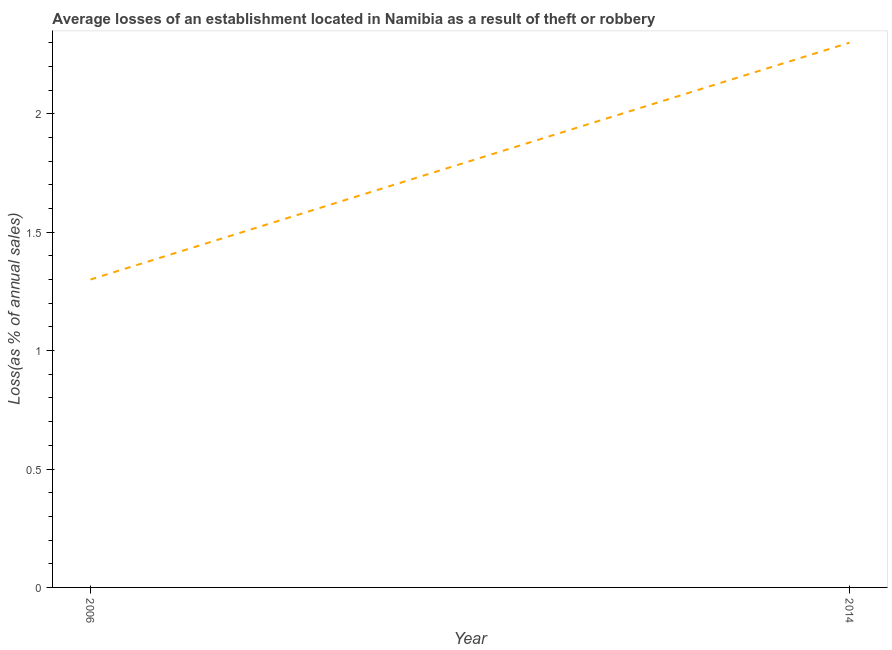Across all years, what is the maximum losses due to theft?
Provide a succinct answer. 2.3. What is the sum of the losses due to theft?
Your response must be concise. 3.6. What is the difference between the losses due to theft in 2006 and 2014?
Give a very brief answer. -1. What is the average losses due to theft per year?
Make the answer very short. 1.8. What is the median losses due to theft?
Make the answer very short. 1.8. Do a majority of the years between 2006 and 2014 (inclusive) have losses due to theft greater than 2 %?
Ensure brevity in your answer.  No. What is the ratio of the losses due to theft in 2006 to that in 2014?
Give a very brief answer. 0.57. Is the losses due to theft in 2006 less than that in 2014?
Give a very brief answer. Yes. In how many years, is the losses due to theft greater than the average losses due to theft taken over all years?
Your answer should be very brief. 1. What is the difference between two consecutive major ticks on the Y-axis?
Offer a terse response. 0.5. Does the graph contain any zero values?
Provide a short and direct response. No. Does the graph contain grids?
Give a very brief answer. No. What is the title of the graph?
Ensure brevity in your answer.  Average losses of an establishment located in Namibia as a result of theft or robbery. What is the label or title of the Y-axis?
Your answer should be compact. Loss(as % of annual sales). What is the Loss(as % of annual sales) of 2006?
Give a very brief answer. 1.3. What is the Loss(as % of annual sales) of 2014?
Keep it short and to the point. 2.3. What is the ratio of the Loss(as % of annual sales) in 2006 to that in 2014?
Your answer should be compact. 0.56. 